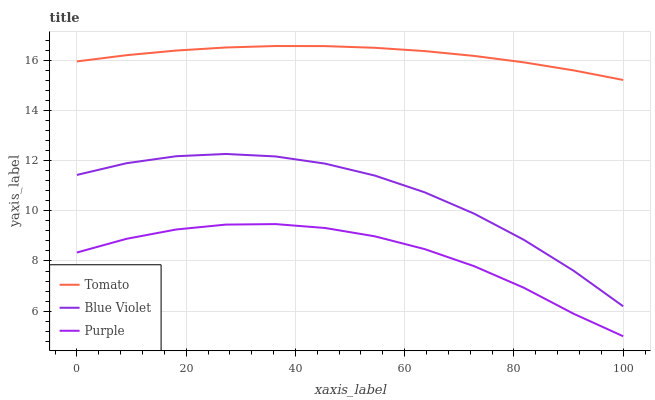Does Purple have the minimum area under the curve?
Answer yes or no. Yes. Does Tomato have the maximum area under the curve?
Answer yes or no. Yes. Does Blue Violet have the minimum area under the curve?
Answer yes or no. No. Does Blue Violet have the maximum area under the curve?
Answer yes or no. No. Is Tomato the smoothest?
Answer yes or no. Yes. Is Blue Violet the roughest?
Answer yes or no. Yes. Is Purple the smoothest?
Answer yes or no. No. Is Purple the roughest?
Answer yes or no. No. Does Purple have the lowest value?
Answer yes or no. Yes. Does Blue Violet have the lowest value?
Answer yes or no. No. Does Tomato have the highest value?
Answer yes or no. Yes. Does Blue Violet have the highest value?
Answer yes or no. No. Is Purple less than Tomato?
Answer yes or no. Yes. Is Tomato greater than Blue Violet?
Answer yes or no. Yes. Does Purple intersect Tomato?
Answer yes or no. No. 